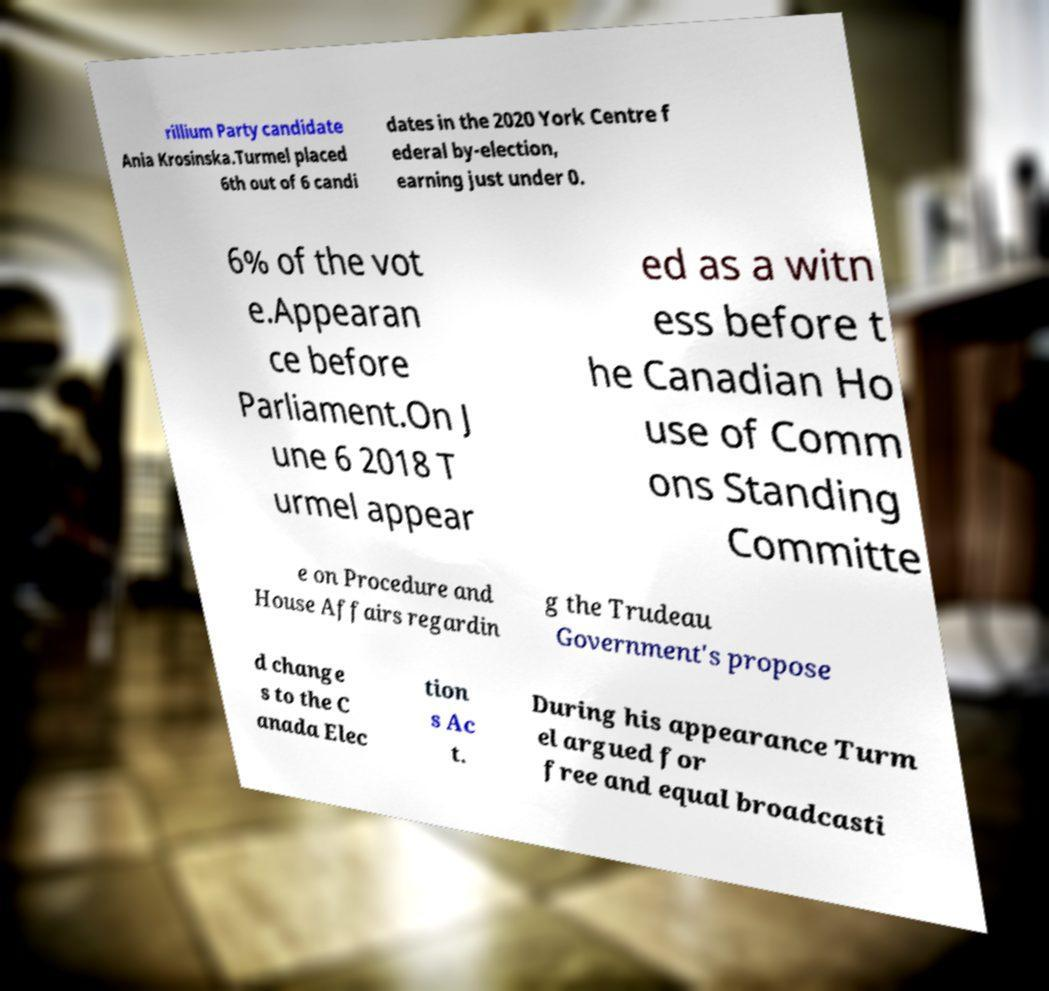For documentation purposes, I need the text within this image transcribed. Could you provide that? rillium Party candidate Ania Krosinska.Turmel placed 6th out of 6 candi dates in the 2020 York Centre f ederal by-election, earning just under 0. 6% of the vot e.Appearan ce before Parliament.On J une 6 2018 T urmel appear ed as a witn ess before t he Canadian Ho use of Comm ons Standing Committe e on Procedure and House Affairs regardin g the Trudeau Government's propose d change s to the C anada Elec tion s Ac t. During his appearance Turm el argued for free and equal broadcasti 